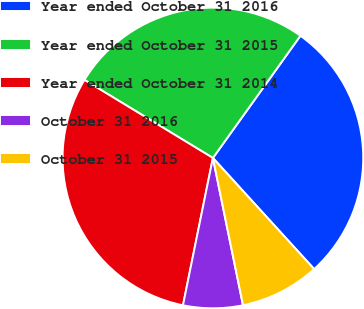Convert chart. <chart><loc_0><loc_0><loc_500><loc_500><pie_chart><fcel>Year ended October 31 2016<fcel>Year ended October 31 2015<fcel>Year ended October 31 2014<fcel>October 31 2016<fcel>October 31 2015<nl><fcel>28.35%<fcel>26.2%<fcel>30.5%<fcel>6.4%<fcel>8.55%<nl></chart> 